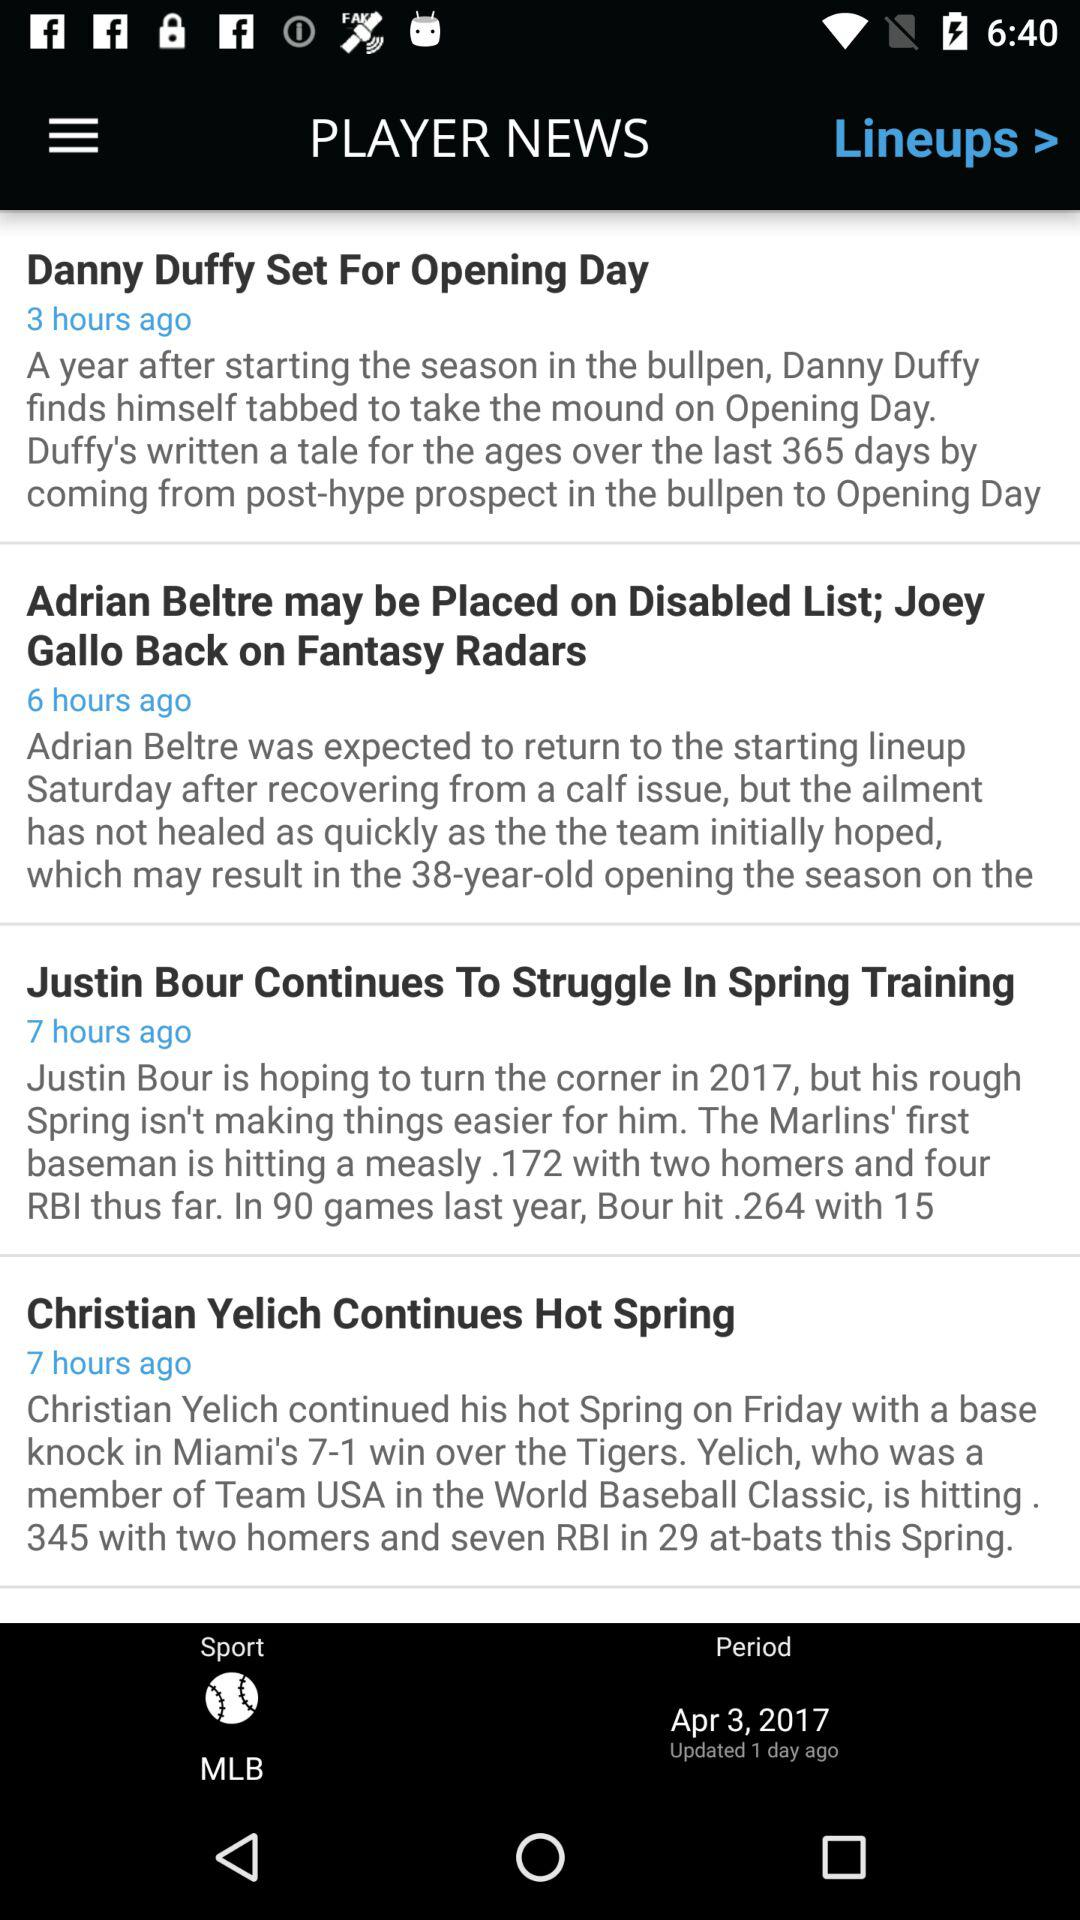What is the "Period" date? The "Period" date is April 3, 2017. 